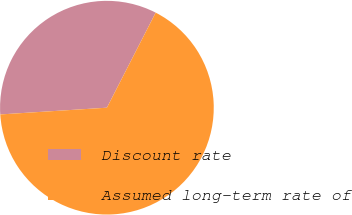Convert chart. <chart><loc_0><loc_0><loc_500><loc_500><pie_chart><fcel>Discount rate<fcel>Assumed long-term rate of<nl><fcel>33.55%<fcel>66.45%<nl></chart> 